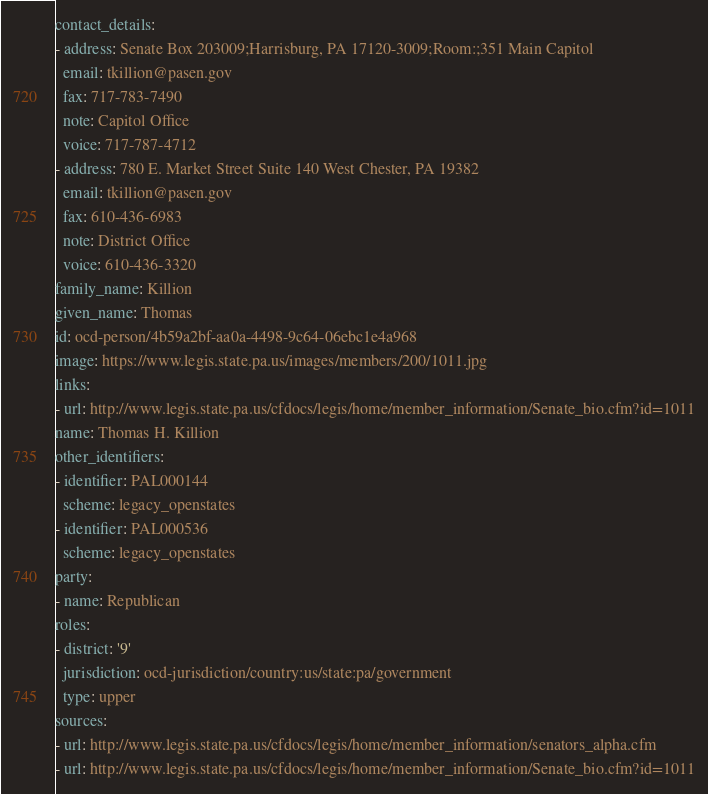<code> <loc_0><loc_0><loc_500><loc_500><_YAML_>contact_details:
- address: Senate Box 203009;Harrisburg, PA 17120-3009;Room:;351 Main Capitol
  email: tkillion@pasen.gov
  fax: 717-783-7490
  note: Capitol Office
  voice: 717-787-4712
- address: 780 E. Market Street Suite 140 West Chester, PA 19382
  email: tkillion@pasen.gov
  fax: 610-436-6983
  note: District Office
  voice: 610-436-3320
family_name: Killion
given_name: Thomas
id: ocd-person/4b59a2bf-aa0a-4498-9c64-06ebc1e4a968
image: https://www.legis.state.pa.us/images/members/200/1011.jpg
links:
- url: http://www.legis.state.pa.us/cfdocs/legis/home/member_information/Senate_bio.cfm?id=1011
name: Thomas H. Killion
other_identifiers:
- identifier: PAL000144
  scheme: legacy_openstates
- identifier: PAL000536
  scheme: legacy_openstates
party:
- name: Republican
roles:
- district: '9'
  jurisdiction: ocd-jurisdiction/country:us/state:pa/government
  type: upper
sources:
- url: http://www.legis.state.pa.us/cfdocs/legis/home/member_information/senators_alpha.cfm
- url: http://www.legis.state.pa.us/cfdocs/legis/home/member_information/Senate_bio.cfm?id=1011
</code> 